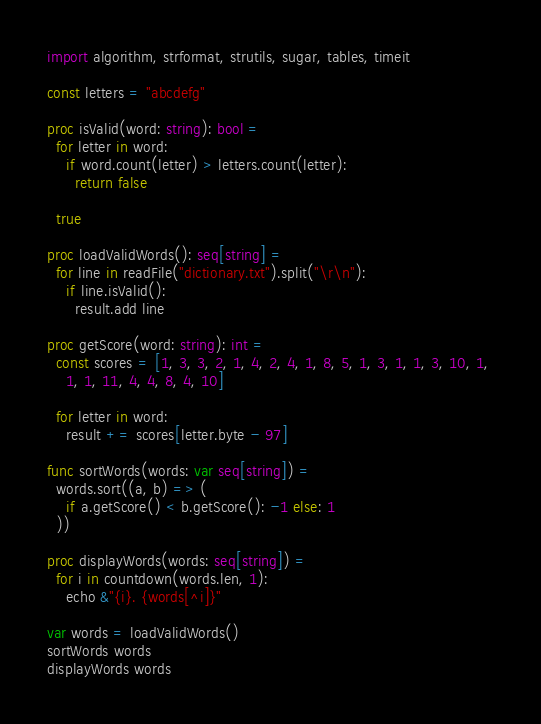<code> <loc_0><loc_0><loc_500><loc_500><_Nim_>import algorithm, strformat, strutils, sugar, tables, timeit

const letters = "abcdefg"

proc isValid(word: string): bool =
  for letter in word:
    if word.count(letter) > letters.count(letter):
      return false
    
  true

proc loadValidWords(): seq[string] =
  for line in readFile("dictionary.txt").split("\r\n"):
    if line.isValid():
      result.add line

proc getScore(word: string): int =
  const scores = [1, 3, 3, 2, 1, 4, 2, 4, 1, 8, 5, 1, 3, 1, 1, 3, 10, 1, 
    1, 1, 11, 4, 4, 8, 4, 10]

  for letter in word:
    result += scores[letter.byte - 97]

func sortWords(words: var seq[string]) =
  words.sort((a, b) => (
    if a.getScore() < b.getScore(): -1 else: 1
  ))

proc displayWords(words: seq[string]) =
  for i in countdown(words.len, 1):
    echo &"{i}. {words[^i]}"

var words = loadValidWords()
sortWords words
displayWords words
</code> 